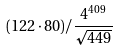Convert formula to latex. <formula><loc_0><loc_0><loc_500><loc_500>( 1 2 2 \cdot 8 0 ) / \frac { 4 ^ { 4 0 9 } } { \sqrt { 4 4 9 } }</formula> 